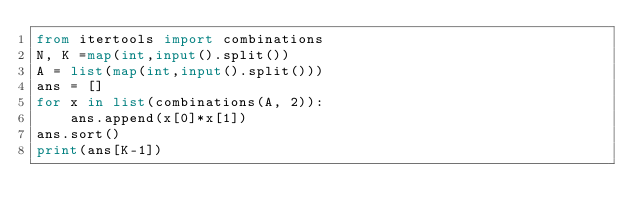Convert code to text. <code><loc_0><loc_0><loc_500><loc_500><_Python_>from itertools import combinations
N, K =map(int,input().split())
A = list(map(int,input().split()))
ans = []
for x in list(combinations(A, 2)):
    ans.append(x[0]*x[1])
ans.sort()
print(ans[K-1])</code> 